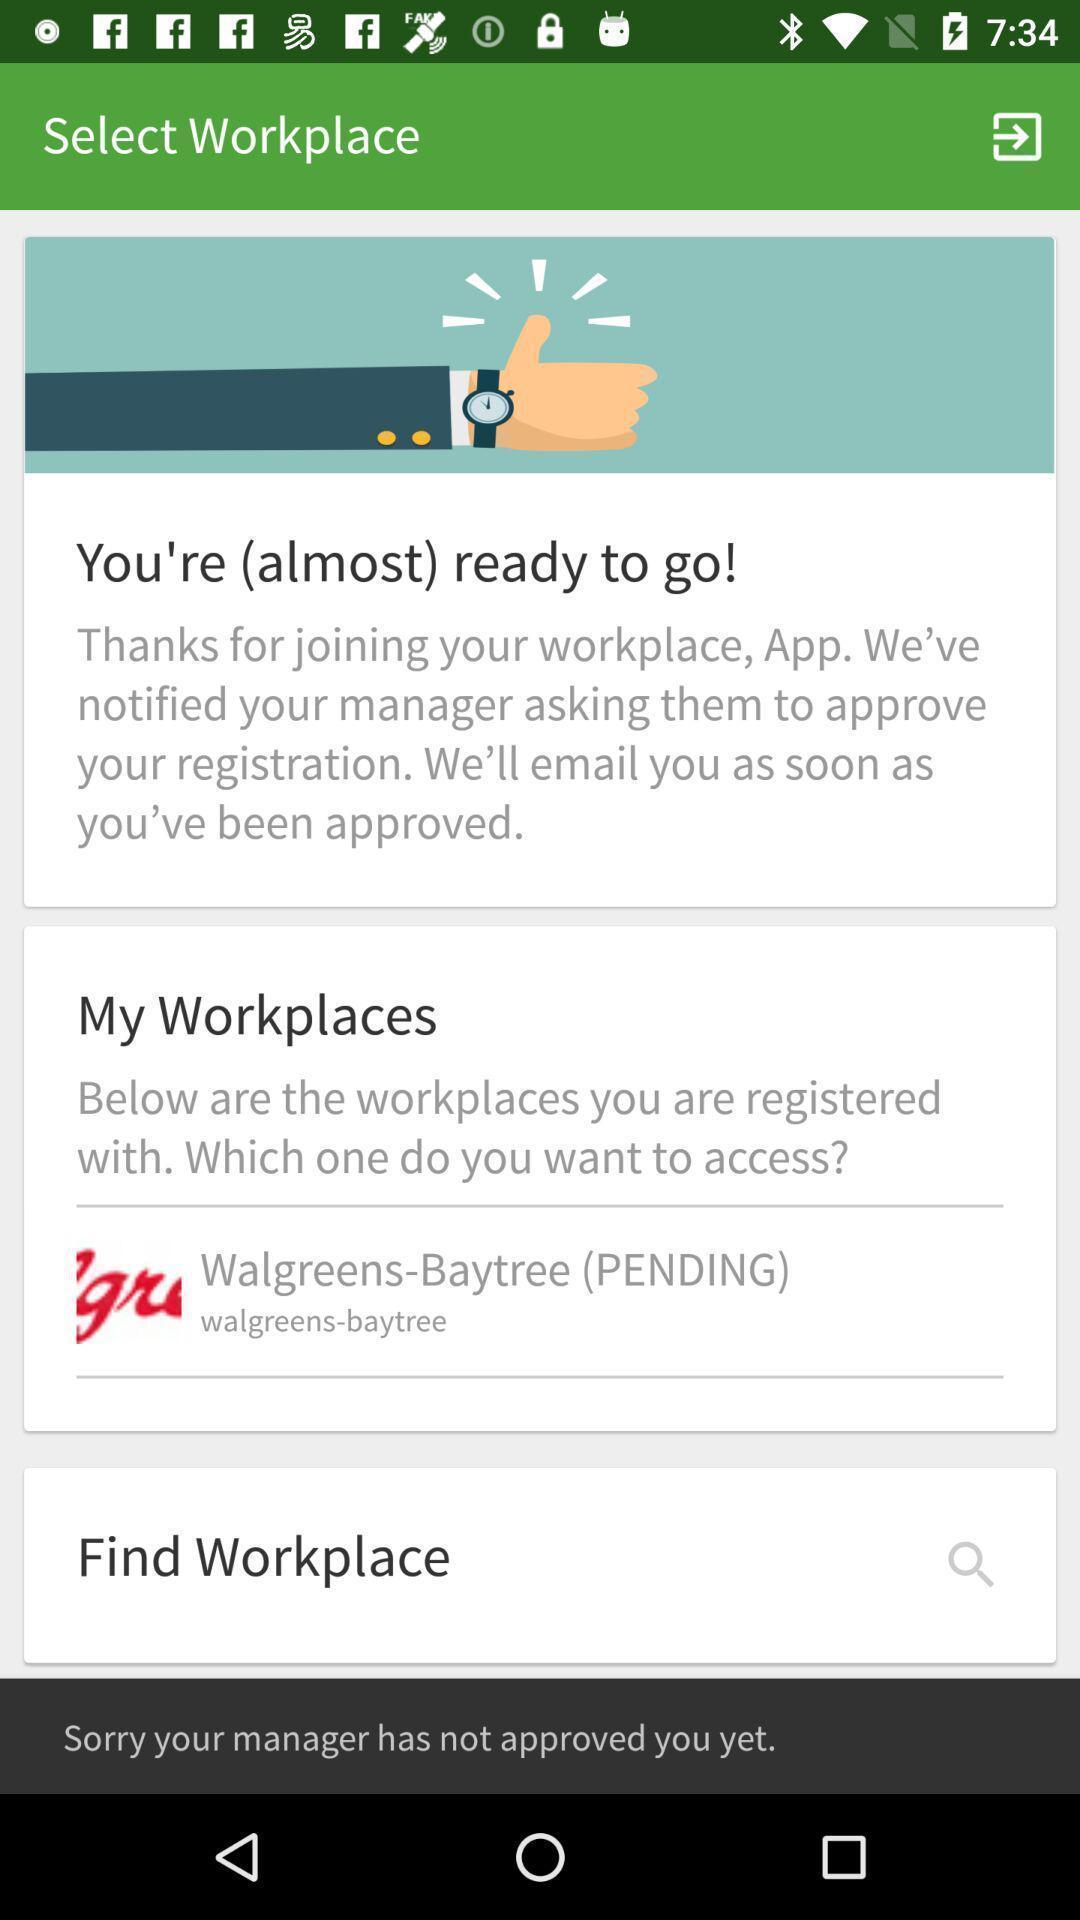Explain what's happening in this screen capture. Screen displaying the description of work place. 